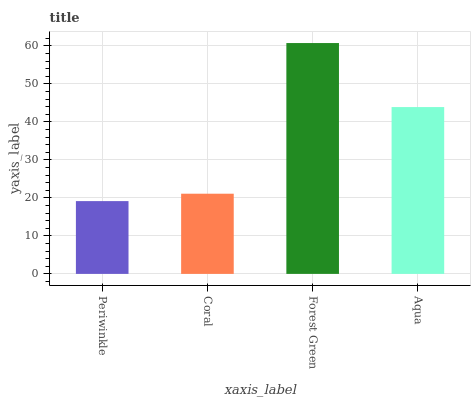Is Coral the minimum?
Answer yes or no. No. Is Coral the maximum?
Answer yes or no. No. Is Coral greater than Periwinkle?
Answer yes or no. Yes. Is Periwinkle less than Coral?
Answer yes or no. Yes. Is Periwinkle greater than Coral?
Answer yes or no. No. Is Coral less than Periwinkle?
Answer yes or no. No. Is Aqua the high median?
Answer yes or no. Yes. Is Coral the low median?
Answer yes or no. Yes. Is Forest Green the high median?
Answer yes or no. No. Is Aqua the low median?
Answer yes or no. No. 